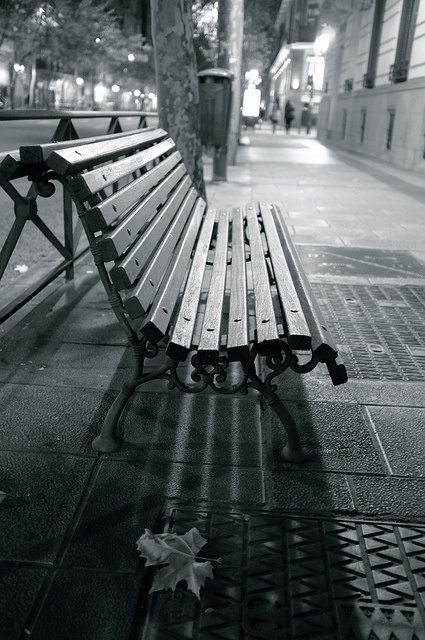Describe the objects in this image and their specific colors. I can see bench in black, darkgray, lightgray, and gray tones, people in black, gray, purple, and darkgray tones, people in black, gray, darkgray, and purple tones, and people in black, purple, darkgray, and gray tones in this image. 